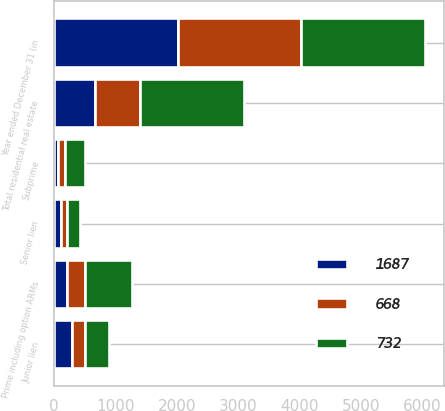Convert chart. <chart><loc_0><loc_0><loc_500><loc_500><stacked_bar_chart><ecel><fcel>Year ended December 31 (in<fcel>Senior lien<fcel>Junior lien<fcel>Prime including option ARMs<fcel>Subprime<fcel>Total residential real estate<nl><fcel>1687<fcel>2015<fcel>108<fcel>293<fcel>209<fcel>58<fcel>668<nl><fcel>668<fcel>2014<fcel>110<fcel>211<fcel>287<fcel>124<fcel>732<nl><fcel>732<fcel>2013<fcel>210<fcel>388<fcel>770<fcel>319<fcel>1687<nl></chart> 